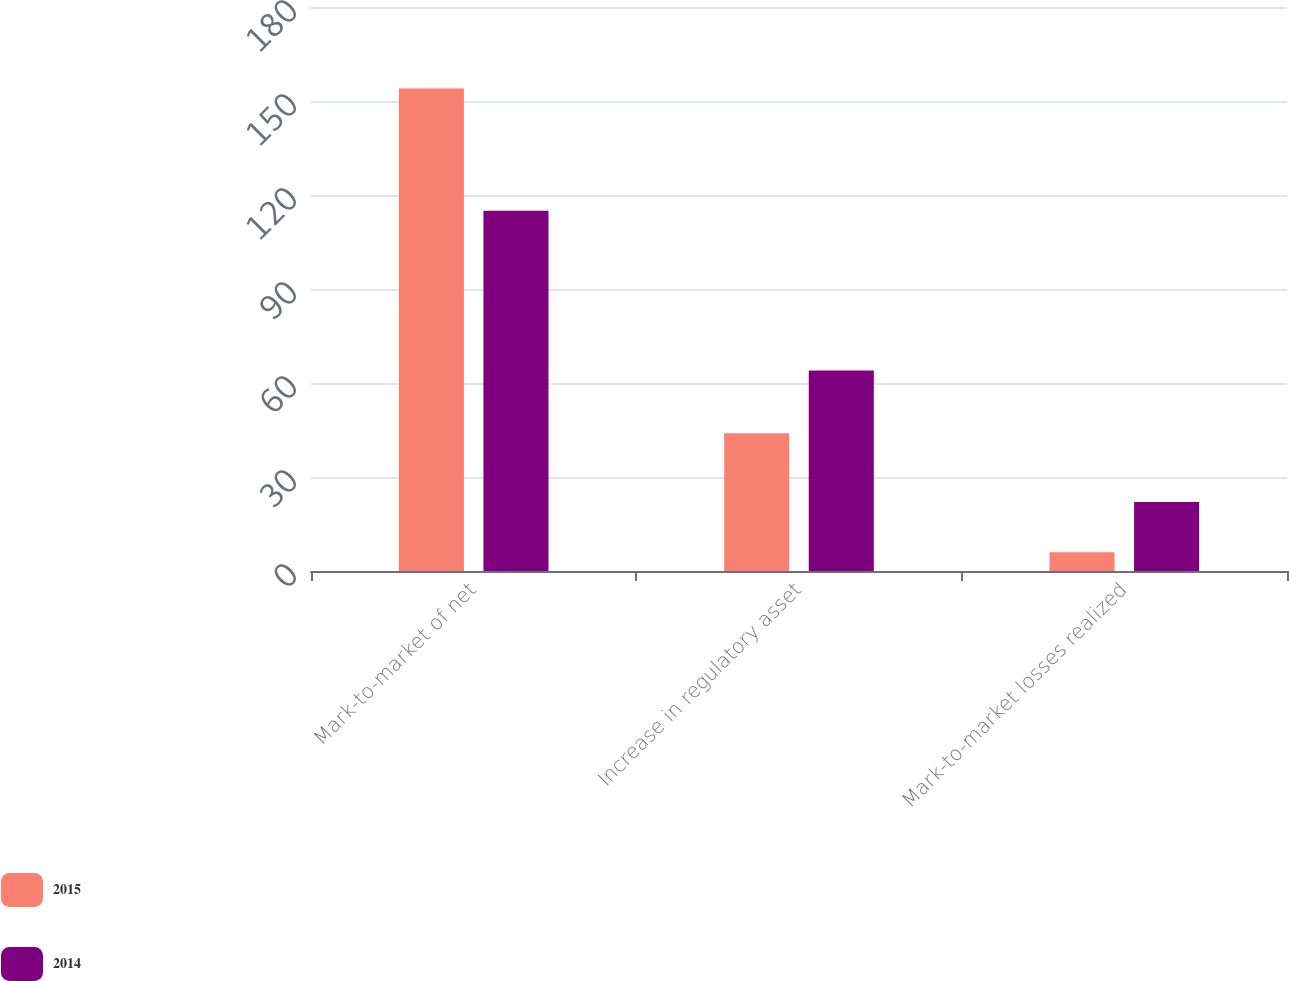<chart> <loc_0><loc_0><loc_500><loc_500><stacked_bar_chart><ecel><fcel>Mark-to-market of net<fcel>Increase in regulatory asset<fcel>Mark-to-market losses realized<nl><fcel>2015<fcel>154<fcel>44<fcel>6<nl><fcel>2014<fcel>115<fcel>64<fcel>22<nl></chart> 